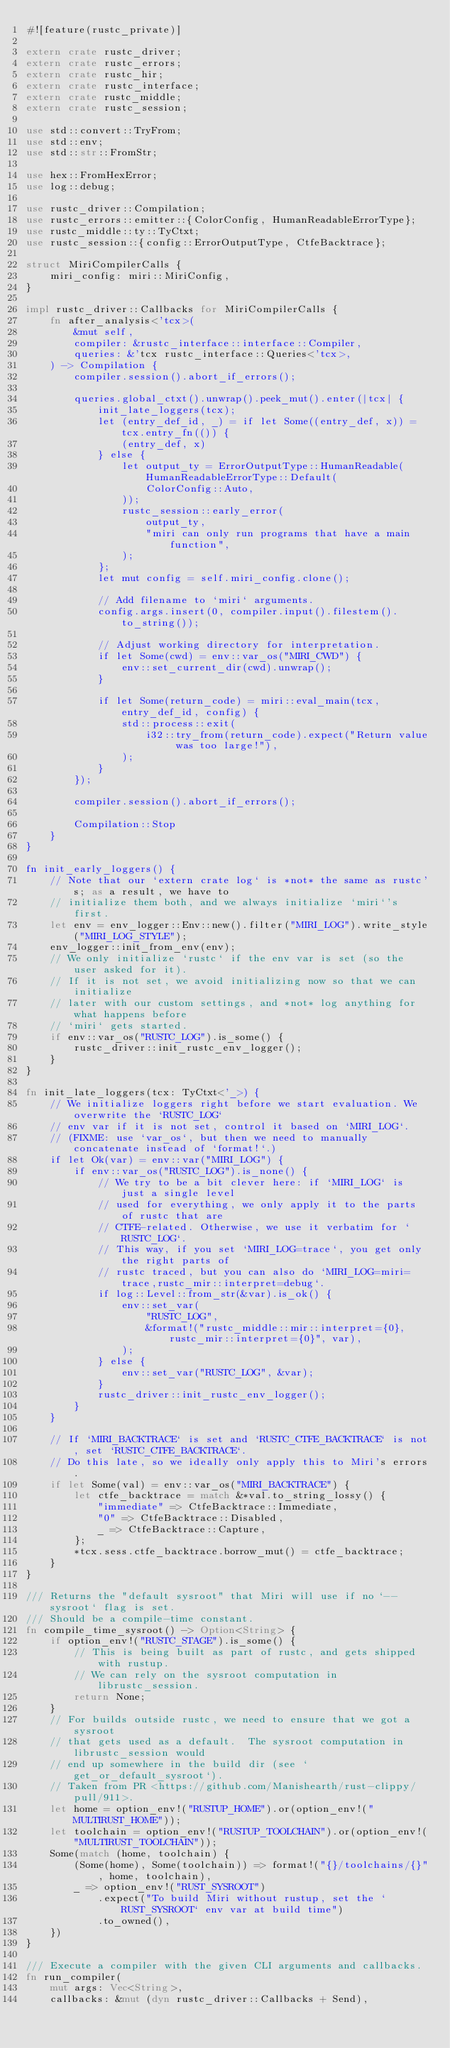Convert code to text. <code><loc_0><loc_0><loc_500><loc_500><_Rust_>#![feature(rustc_private)]

extern crate rustc_driver;
extern crate rustc_errors;
extern crate rustc_hir;
extern crate rustc_interface;
extern crate rustc_middle;
extern crate rustc_session;

use std::convert::TryFrom;
use std::env;
use std::str::FromStr;

use hex::FromHexError;
use log::debug;

use rustc_driver::Compilation;
use rustc_errors::emitter::{ColorConfig, HumanReadableErrorType};
use rustc_middle::ty::TyCtxt;
use rustc_session::{config::ErrorOutputType, CtfeBacktrace};

struct MiriCompilerCalls {
    miri_config: miri::MiriConfig,
}

impl rustc_driver::Callbacks for MiriCompilerCalls {
    fn after_analysis<'tcx>(
        &mut self,
        compiler: &rustc_interface::interface::Compiler,
        queries: &'tcx rustc_interface::Queries<'tcx>,
    ) -> Compilation {
        compiler.session().abort_if_errors();

        queries.global_ctxt().unwrap().peek_mut().enter(|tcx| {
            init_late_loggers(tcx);
            let (entry_def_id, _) = if let Some((entry_def, x)) = tcx.entry_fn(()) {
                (entry_def, x)
            } else {
                let output_ty = ErrorOutputType::HumanReadable(HumanReadableErrorType::Default(
                    ColorConfig::Auto,
                ));
                rustc_session::early_error(
                    output_ty,
                    "miri can only run programs that have a main function",
                );
            };
            let mut config = self.miri_config.clone();

            // Add filename to `miri` arguments.
            config.args.insert(0, compiler.input().filestem().to_string());

            // Adjust working directory for interpretation.
            if let Some(cwd) = env::var_os("MIRI_CWD") {
                env::set_current_dir(cwd).unwrap();
            }

            if let Some(return_code) = miri::eval_main(tcx, entry_def_id, config) {
                std::process::exit(
                    i32::try_from(return_code).expect("Return value was too large!"),
                );
            }
        });

        compiler.session().abort_if_errors();

        Compilation::Stop
    }
}

fn init_early_loggers() {
    // Note that our `extern crate log` is *not* the same as rustc's; as a result, we have to
    // initialize them both, and we always initialize `miri`'s first.
    let env = env_logger::Env::new().filter("MIRI_LOG").write_style("MIRI_LOG_STYLE");
    env_logger::init_from_env(env);
    // We only initialize `rustc` if the env var is set (so the user asked for it).
    // If it is not set, we avoid initializing now so that we can initialize
    // later with our custom settings, and *not* log anything for what happens before
    // `miri` gets started.
    if env::var_os("RUSTC_LOG").is_some() {
        rustc_driver::init_rustc_env_logger();
    }
}

fn init_late_loggers(tcx: TyCtxt<'_>) {
    // We initialize loggers right before we start evaluation. We overwrite the `RUSTC_LOG`
    // env var if it is not set, control it based on `MIRI_LOG`.
    // (FIXME: use `var_os`, but then we need to manually concatenate instead of `format!`.)
    if let Ok(var) = env::var("MIRI_LOG") {
        if env::var_os("RUSTC_LOG").is_none() {
            // We try to be a bit clever here: if `MIRI_LOG` is just a single level
            // used for everything, we only apply it to the parts of rustc that are
            // CTFE-related. Otherwise, we use it verbatim for `RUSTC_LOG`.
            // This way, if you set `MIRI_LOG=trace`, you get only the right parts of
            // rustc traced, but you can also do `MIRI_LOG=miri=trace,rustc_mir::interpret=debug`.
            if log::Level::from_str(&var).is_ok() {
                env::set_var(
                    "RUSTC_LOG",
                    &format!("rustc_middle::mir::interpret={0},rustc_mir::interpret={0}", var),
                );
            } else {
                env::set_var("RUSTC_LOG", &var);
            }
            rustc_driver::init_rustc_env_logger();
        }
    }

    // If `MIRI_BACKTRACE` is set and `RUSTC_CTFE_BACKTRACE` is not, set `RUSTC_CTFE_BACKTRACE`.
    // Do this late, so we ideally only apply this to Miri's errors.
    if let Some(val) = env::var_os("MIRI_BACKTRACE") {
        let ctfe_backtrace = match &*val.to_string_lossy() {
            "immediate" => CtfeBacktrace::Immediate,
            "0" => CtfeBacktrace::Disabled,
            _ => CtfeBacktrace::Capture,
        };
        *tcx.sess.ctfe_backtrace.borrow_mut() = ctfe_backtrace;
    }
}

/// Returns the "default sysroot" that Miri will use if no `--sysroot` flag is set.
/// Should be a compile-time constant.
fn compile_time_sysroot() -> Option<String> {
    if option_env!("RUSTC_STAGE").is_some() {
        // This is being built as part of rustc, and gets shipped with rustup.
        // We can rely on the sysroot computation in librustc_session.
        return None;
    }
    // For builds outside rustc, we need to ensure that we got a sysroot
    // that gets used as a default.  The sysroot computation in librustc_session would
    // end up somewhere in the build dir (see `get_or_default_sysroot`).
    // Taken from PR <https://github.com/Manishearth/rust-clippy/pull/911>.
    let home = option_env!("RUSTUP_HOME").or(option_env!("MULTIRUST_HOME"));
    let toolchain = option_env!("RUSTUP_TOOLCHAIN").or(option_env!("MULTIRUST_TOOLCHAIN"));
    Some(match (home, toolchain) {
        (Some(home), Some(toolchain)) => format!("{}/toolchains/{}", home, toolchain),
        _ => option_env!("RUST_SYSROOT")
            .expect("To build Miri without rustup, set the `RUST_SYSROOT` env var at build time")
            .to_owned(),
    })
}

/// Execute a compiler with the given CLI arguments and callbacks.
fn run_compiler(
    mut args: Vec<String>,
    callbacks: &mut (dyn rustc_driver::Callbacks + Send),</code> 